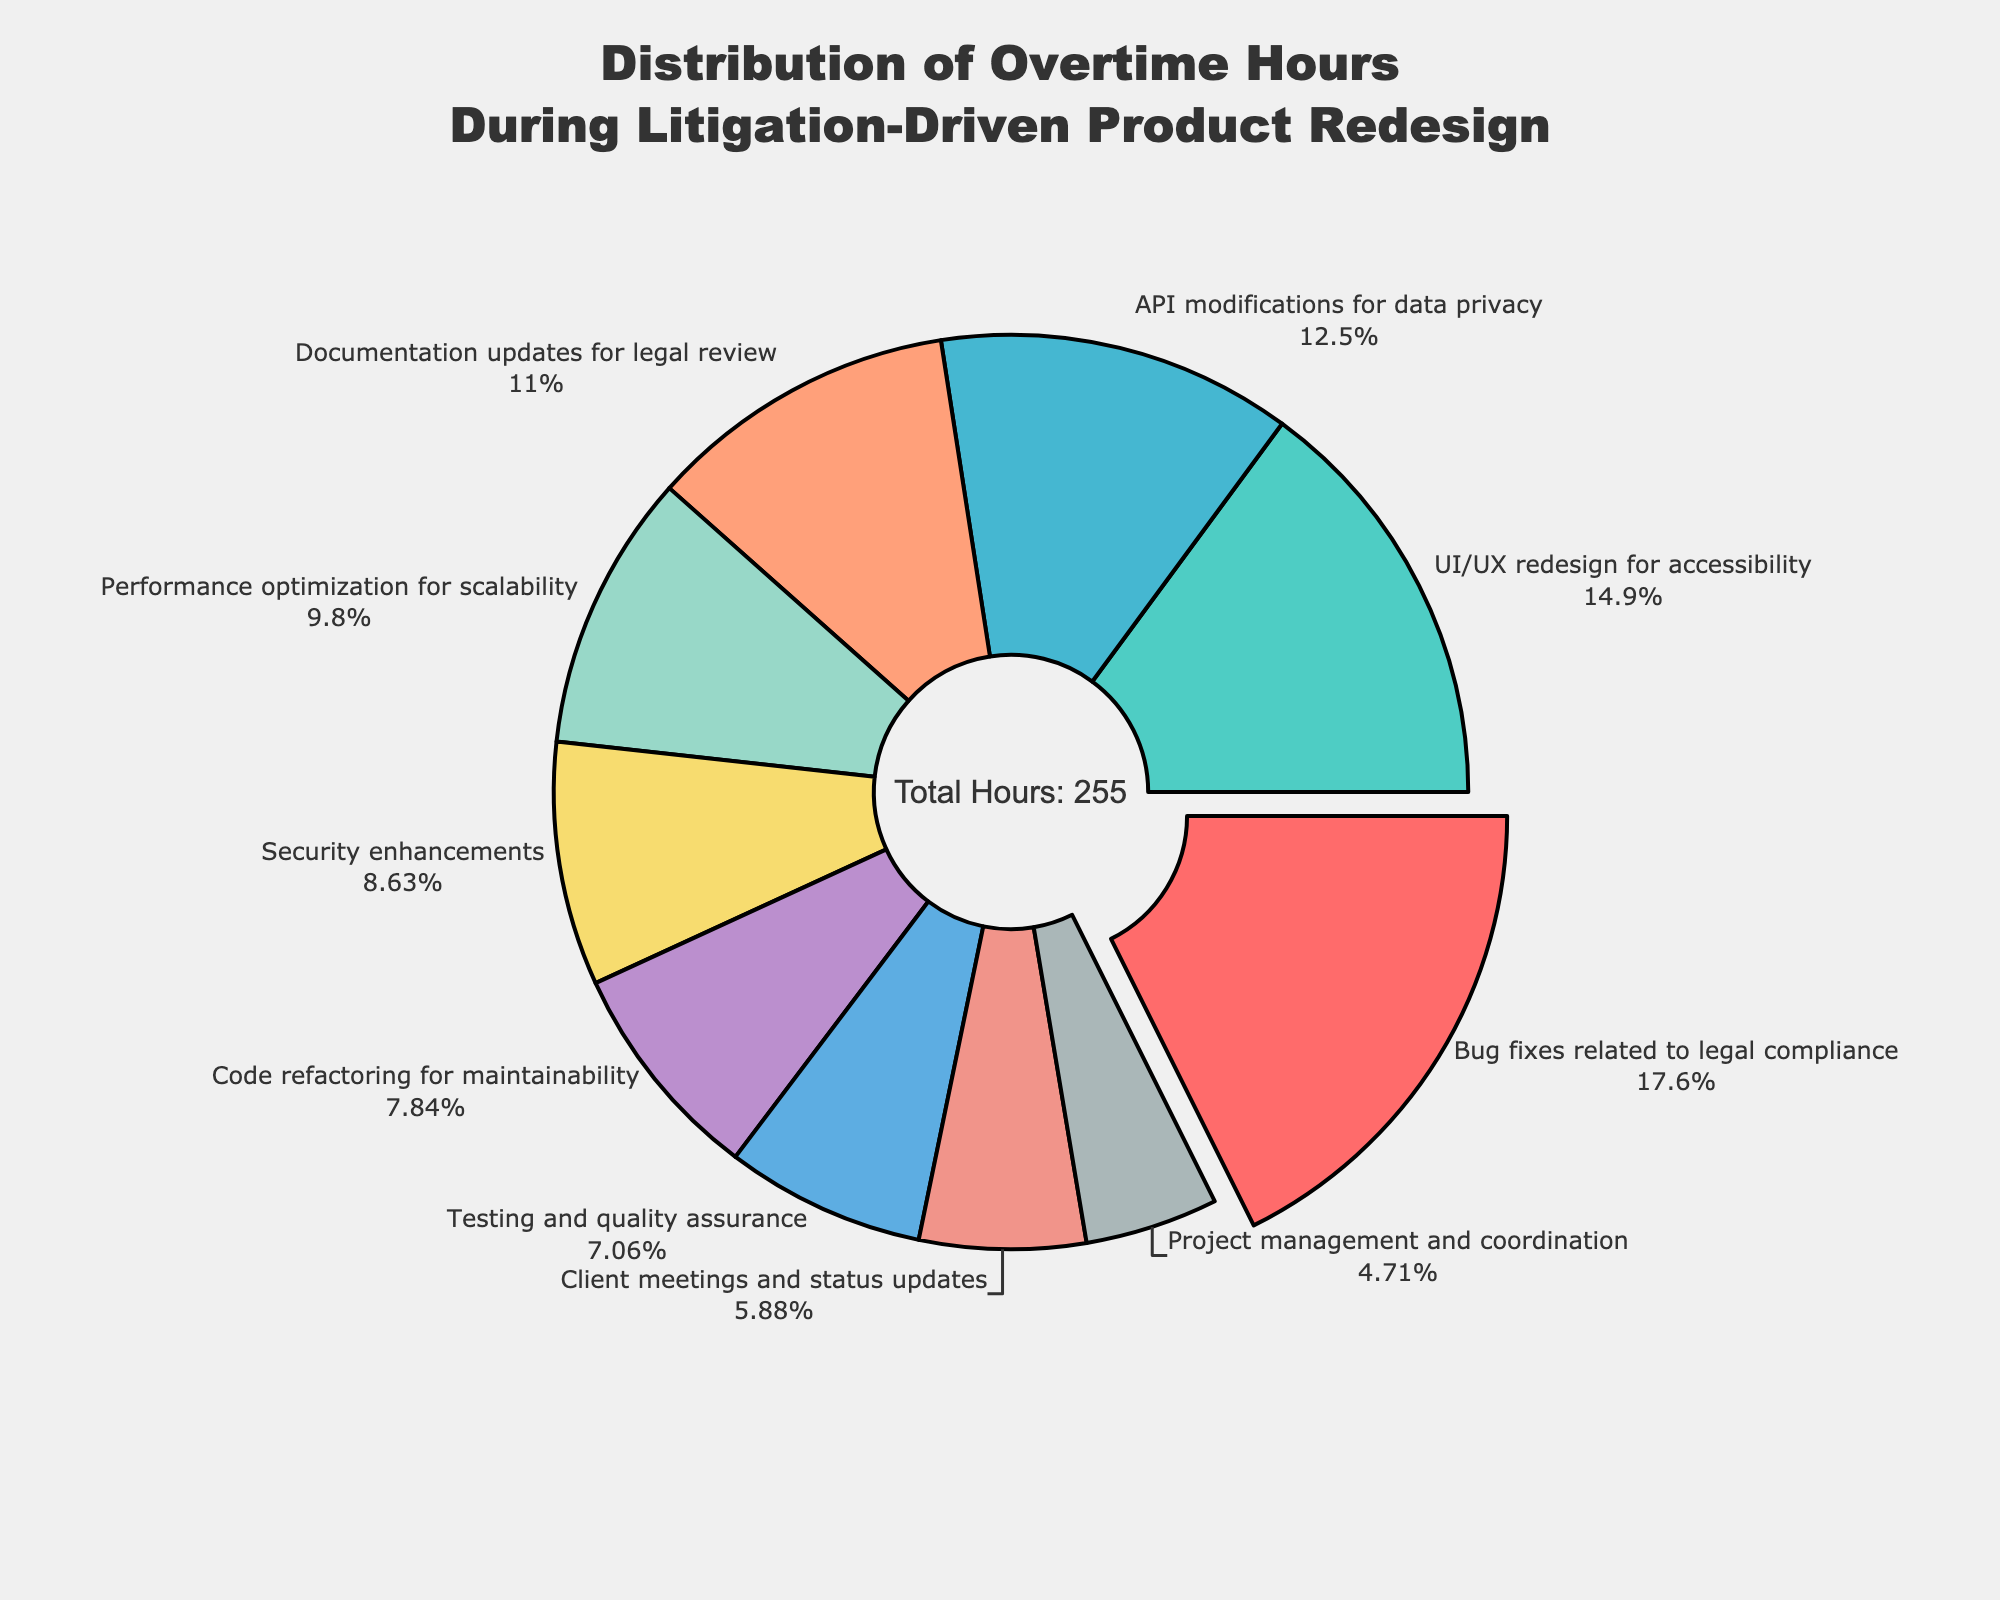What is the percentage of overtime hours spent on bug fixes related to legal compliance? Locate the section labeled "Bug fixes related to legal compliance" and read the percentage provided directly on the pie chart.
Answer: 18.2% Which category has the highest number of overtime hours? Observe the pie chart and look for the section that is slightly pulled out from the rest, which indicates the highest value. The category "Bug fixes related to legal compliance" is the largest segment.
Answer: Bug fixes related to legal compliance How many total overtime hours are distributed across all categories? The total number of hours is annotated at the center of the pie chart. It reads "Total Hours: 255".
Answer: 255 What is the difference between the overtime hours for bug fixes related to legal compliance and performance optimization for scalability? Find the values for both categories from the pie chart: bug fixes related to legal compliance (45 hours) and performance optimization for scalability (25 hours). Subtract the smaller value from the larger value (45 - 25 = 20).
Answer: 20 What is the combined percentage of overtime hours spent on API modifications for data privacy and testing and quality assurance? Locate the percentages for "API modifications for data privacy" and "Testing and quality assurance." Add them together: API modifications (12.5%) + testing and quality assurance (7.1%) = 19.6%.
Answer: 19.6% Which category has fewer overtime hours: client meetings and status updates or project management and coordination? Find the sections for "Client meetings and status updates" (15 hours) and "Project management and coordination" (12 hours) on the pie chart and compare the values.
Answer: Project management and coordination What percentage of overtime hours is spent on security enhancements? Locate the section labeled "Security enhancements" and read the percentage provided directly on the pie chart.
Answer: 8.6% If the overtime hours for documentation updates for legal review were doubled, what would their new percentage be (assuming the total hours remain the same)? Documentation updates currently have 28 hours. Doubling it would make it 56 hours. Calculate the new total hours (255 + 28). Then calculate the new percentage (56 / 283 * 100).
Answer: 19.8% What is the ratio of overtime hours spent on code refactoring for maintainability to UI/UX redesign for accessibility? Find the values for both categories from the pie chart: code refactoring for maintainability (20 hours) and UI/UX redesign for accessibility (38 hours). Divide the smaller value by the larger one (20/38).
Answer: 0.53 